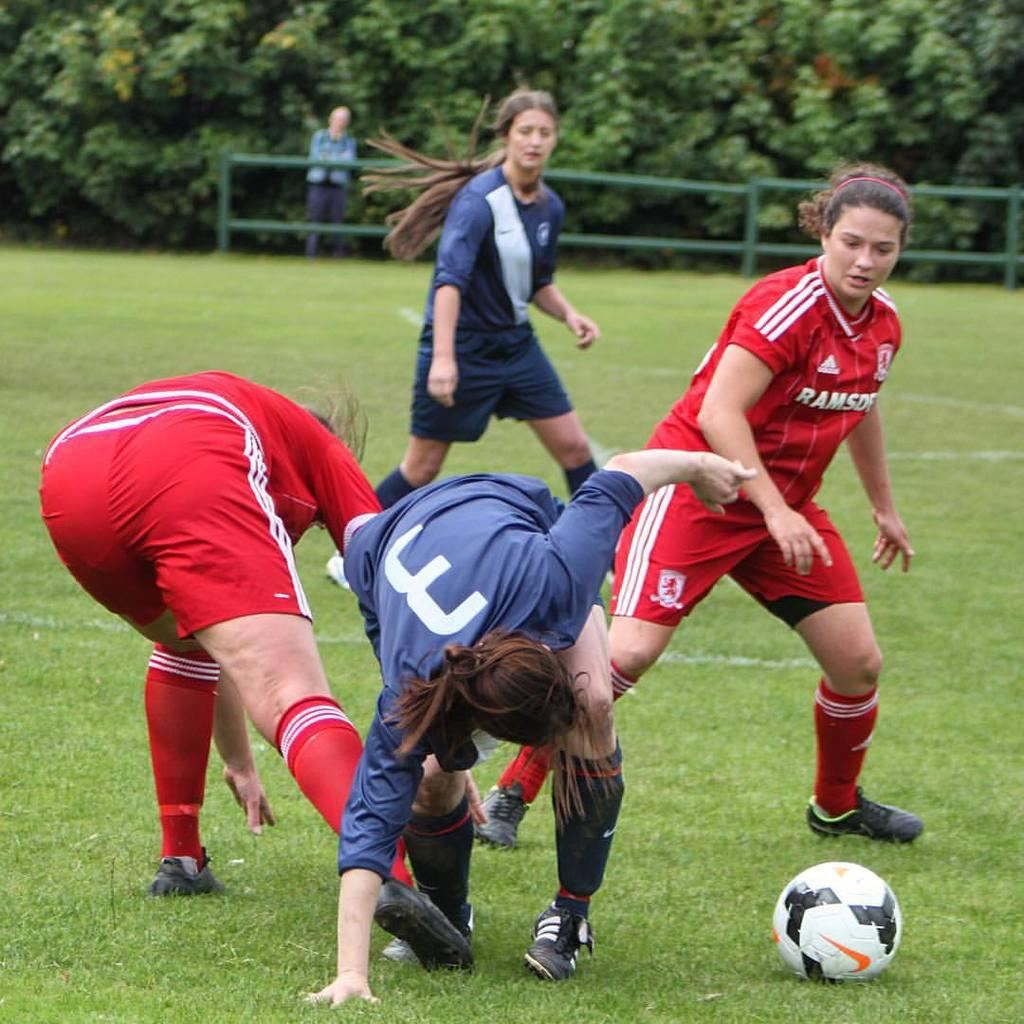Provide a one-sentence caption for the provided image. females playing soccer, 2 wearing blue and 2 wearing red with letters Ramsd showing on front. 